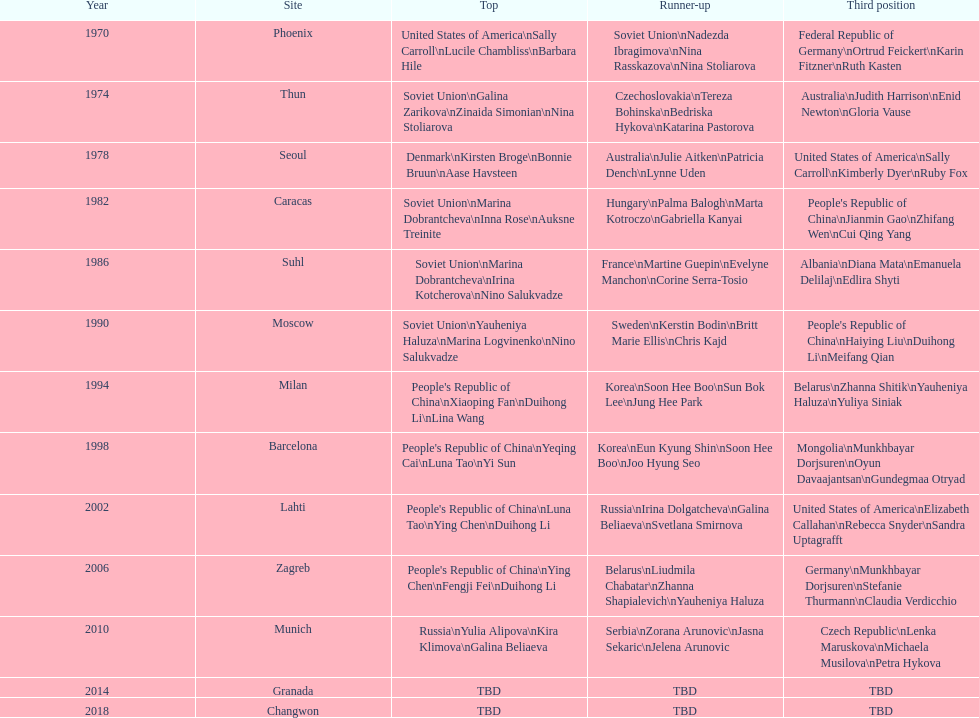How many times has germany won bronze? 2. 